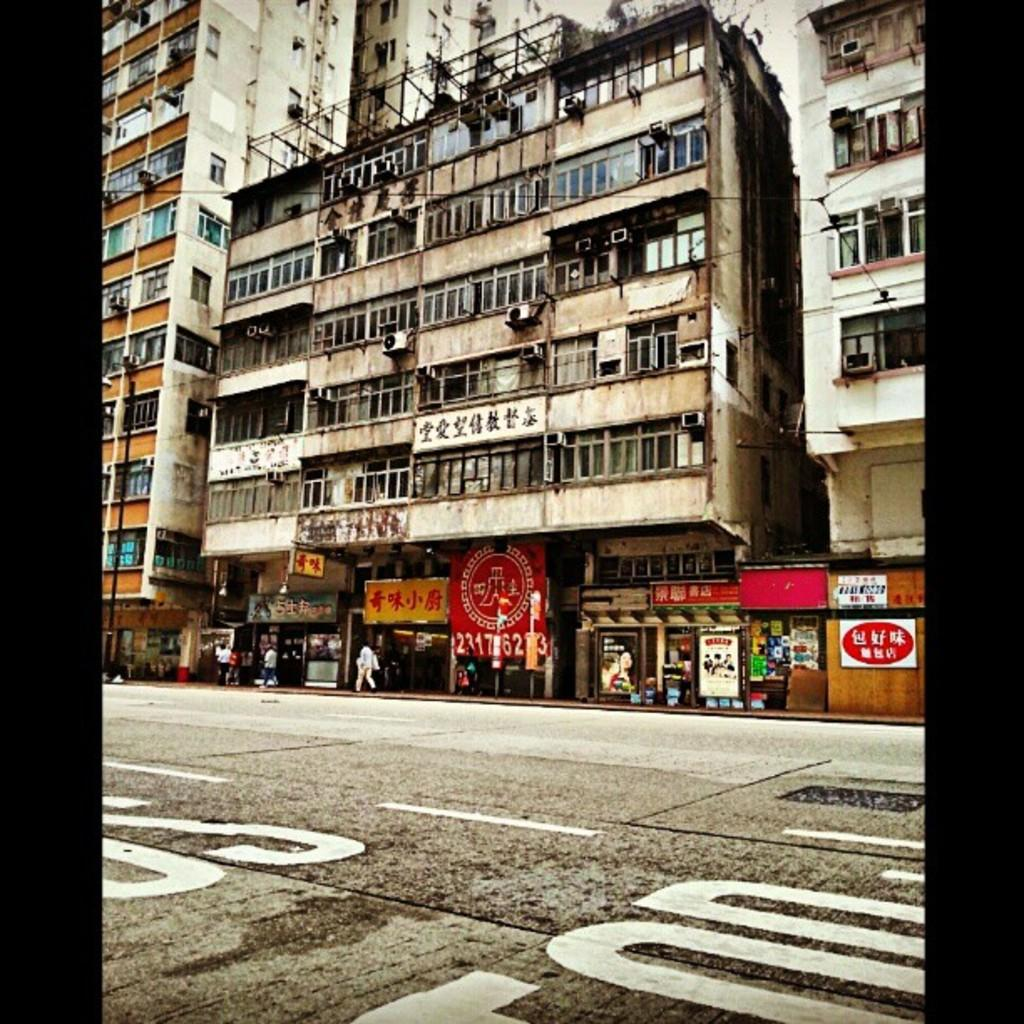What type of structures can be seen in the image? There are buildings in the image. Can you describe the people in the image? There is a group of people in front of the buildings. What else can be seen in the image besides the buildings and people? There are poles and hoardings visible in the image. What type of beast is roaming around the buildings in the image? There is no beast present in the image; it only features buildings, a group of people, poles, and hoardings. 